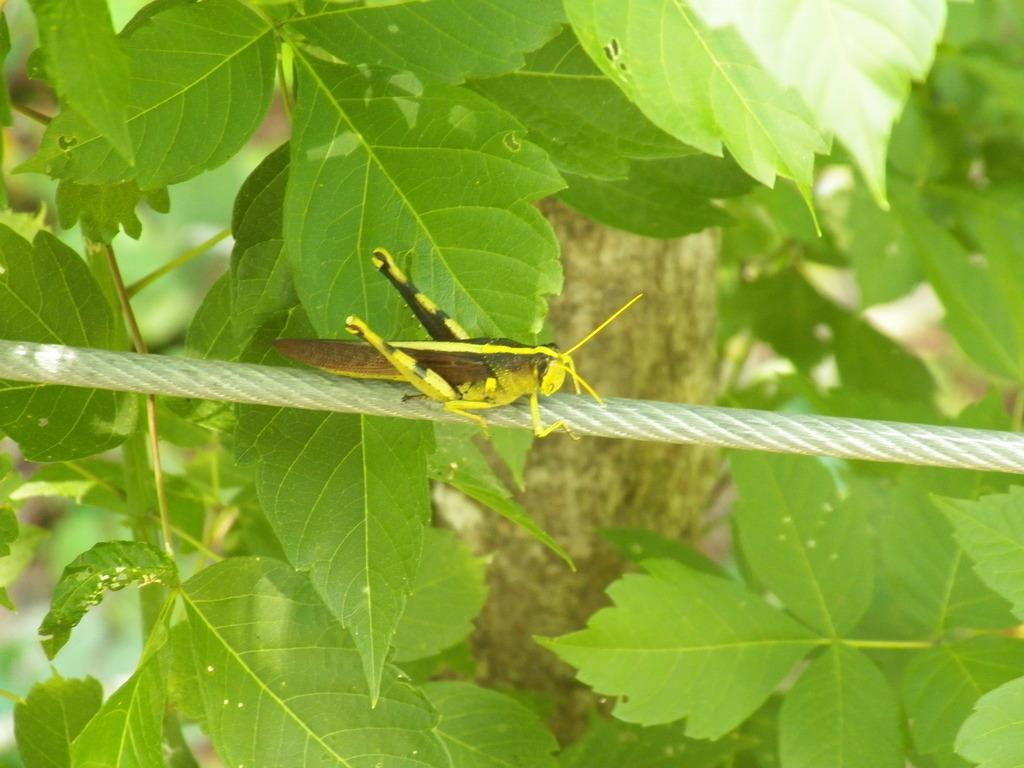Can you describe this image briefly? In this image we can see a grasshopper which is on the thread and at the background of the image there are some leaves. 